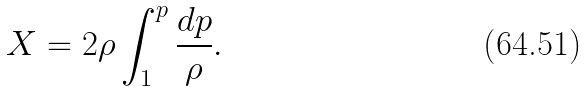<formula> <loc_0><loc_0><loc_500><loc_500>X = 2 \rho \int _ { 1 } ^ { p } \frac { d p } \rho .</formula> 